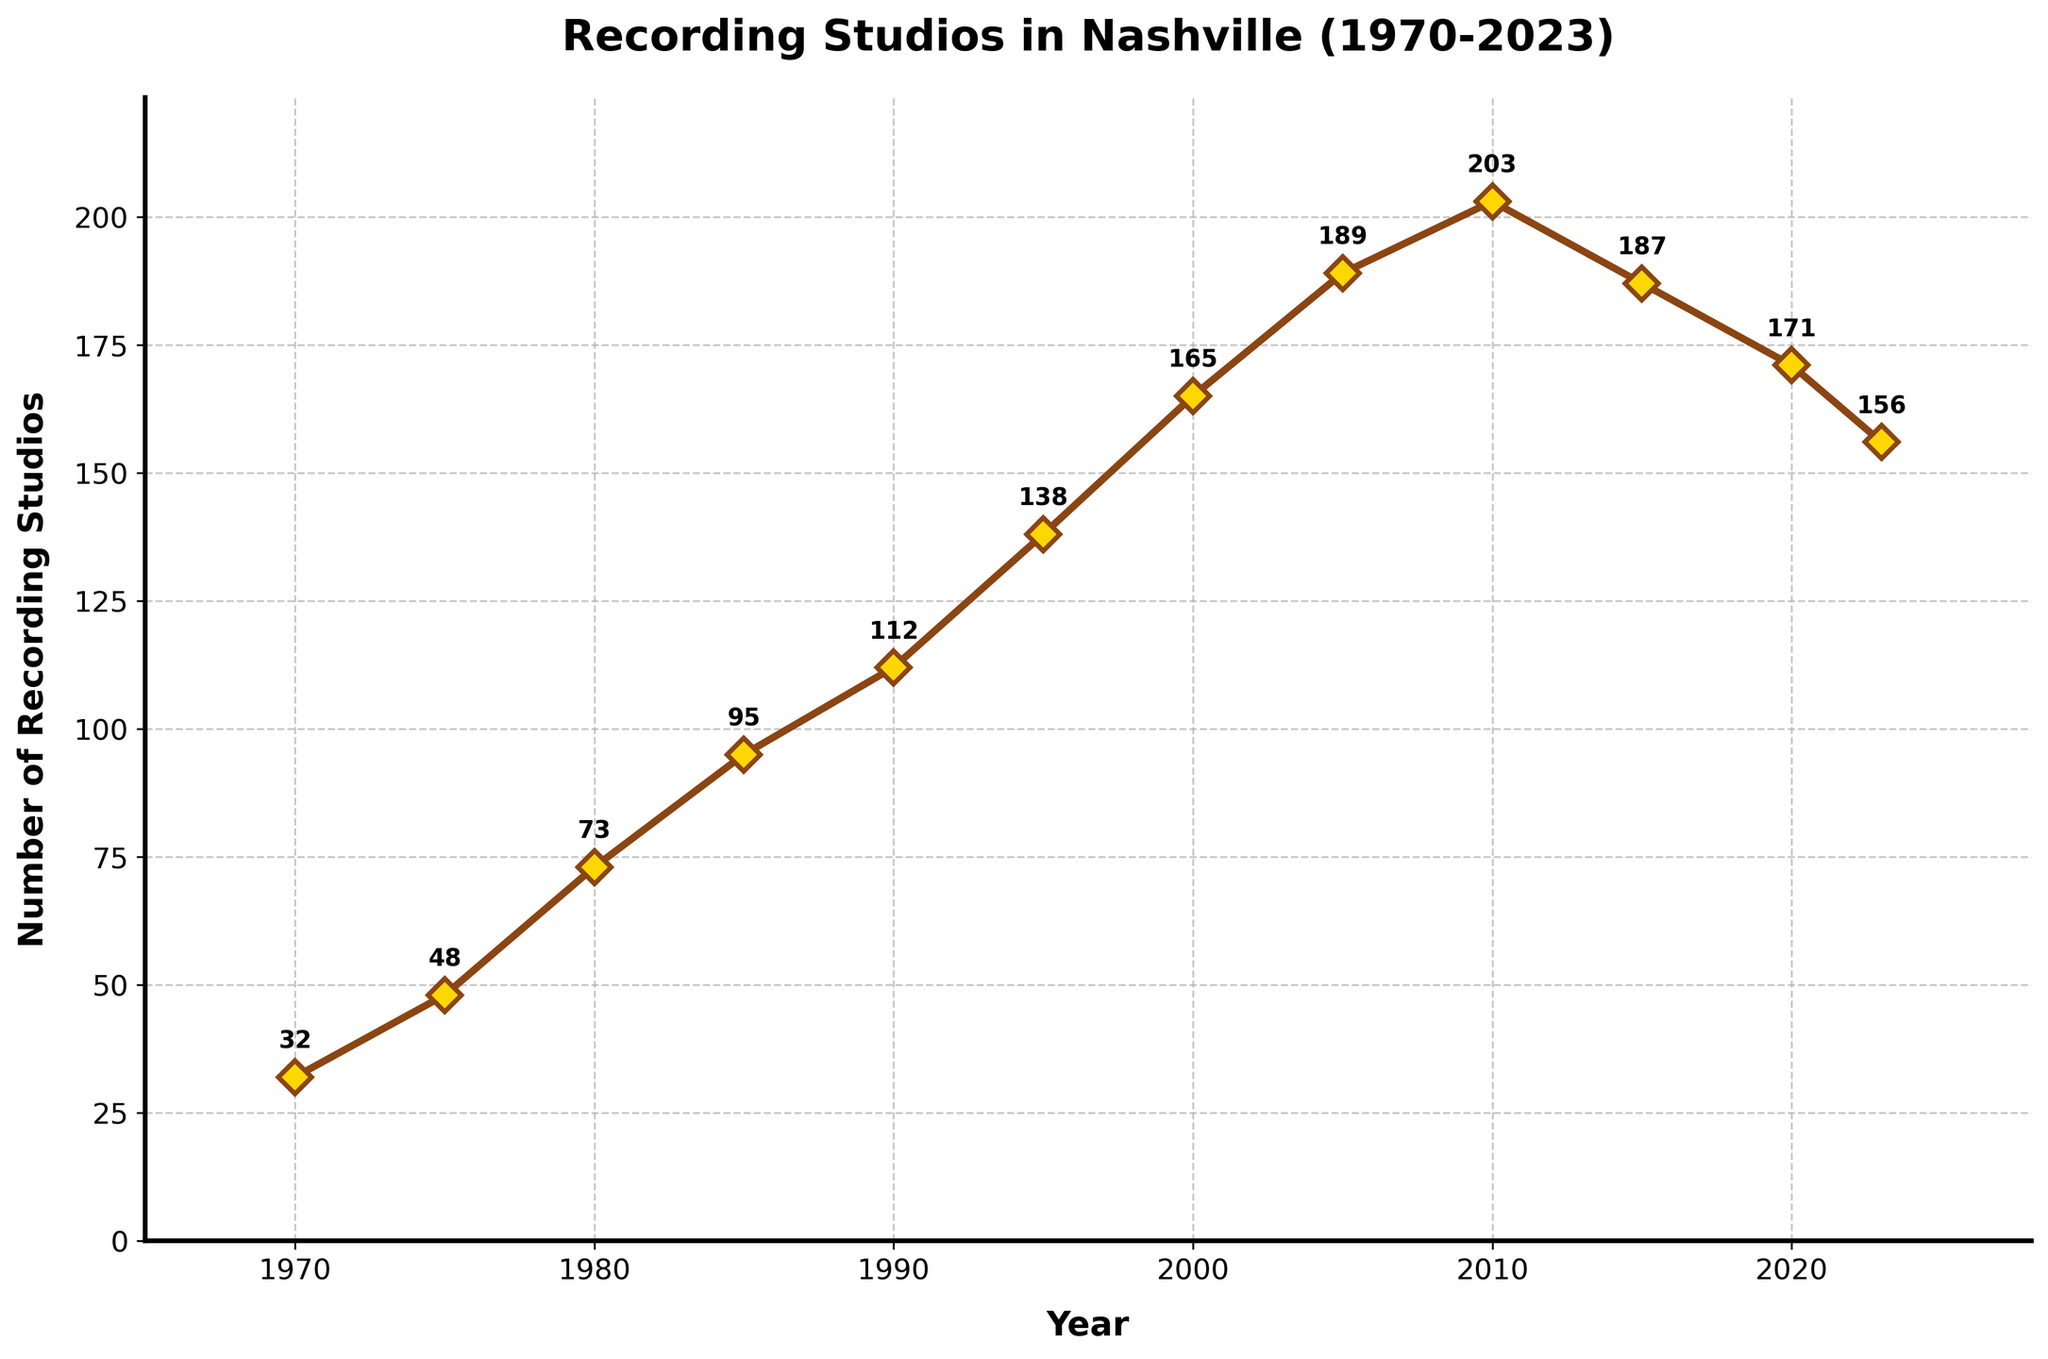What is the range of the number of recording studios shown in the chart? To find the range, we need to subtract the smallest value from the largest value. The smallest number of studios is 32 (in 1970), and the largest is 203 (in 2010). Therefore, the range is 203 - 32.
Answer: 171 How many years show a decrease in the number of recording studios from the previous recorded year? By visually inspecting the chart, we can see decreases for the years 2015, 2020, and 2023 compared to their prior years, 2010, 2015, and 2020 respectively.
Answer: 3 What is the average number of recording studios between 1970 and 2023? Sum all the recorded values: 32 + 48 + 73 + 95 + 112 + 138 + 165 + 189 + 203 + 187 + 171 + 156 = 1569 and then divide by the number of data points, which is 12. The average is 1569 / 12.
Answer: 130.75 What is the percentage decrease in the number of recording studios from 2010 to 2023? To find the percentage decrease, we use the formula [(initial value - final value) / initial value] * 100.
Initial value (2010): 203
Final value (2023): 156
Percentage decrease: [(203 - 156) / 203] * 100 ≈ 23.15%.
Answer: 23.15% What year marks the peak number of recording studios? By visually inspecting the line chart, we see that the highest data point is in the year 2010, with 203 recording studios.
Answer: 2010 Is the number of recording studios in 2023 more than triple the number in 1970? Tripling the number of studios in 1970 (32) gives 32 * 3 = 96. The number of studios in 2023 is 156, which is more than 96.
Answer: Yes What is the median number of recording studios from 1970 to 2023? To find the median, we list the values in ascending order and find the middle value. If there's an even number of values, we average the two middle values.
Sorted values: 32, 48, 73, 95, 112, 138, 156, 165, 171, 187, 189, 203
There are 12 values, so the median is the average of the 6th and 7th values: (138 + 156) / 2.
Answer: 147 